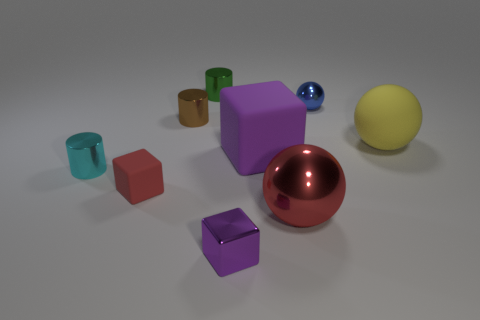Does the red object to the right of the tiny green cylinder have the same material as the purple thing in front of the big metallic thing?
Give a very brief answer. Yes. What is the material of the tiny blue object that is the same shape as the yellow matte thing?
Make the answer very short. Metal. Does the large yellow sphere have the same material as the brown thing?
Your response must be concise. No. There is a metal sphere that is on the right side of the sphere that is to the left of the tiny blue thing; what is its color?
Provide a short and direct response. Blue. What size is the red cube that is the same material as the big yellow ball?
Keep it short and to the point. Small. How many big gray things have the same shape as the large red thing?
Your response must be concise. 0. How many things are blocks that are on the right side of the small brown metallic cylinder or matte things in front of the big yellow matte sphere?
Give a very brief answer. 3. There is a purple block behind the red ball; how many large purple blocks are behind it?
Offer a terse response. 0. Is the shape of the tiny metal thing in front of the tiny cyan cylinder the same as the matte thing that is on the left side of the purple matte cube?
Offer a terse response. Yes. What shape is the small rubber object that is the same color as the big metallic sphere?
Your answer should be very brief. Cube. 